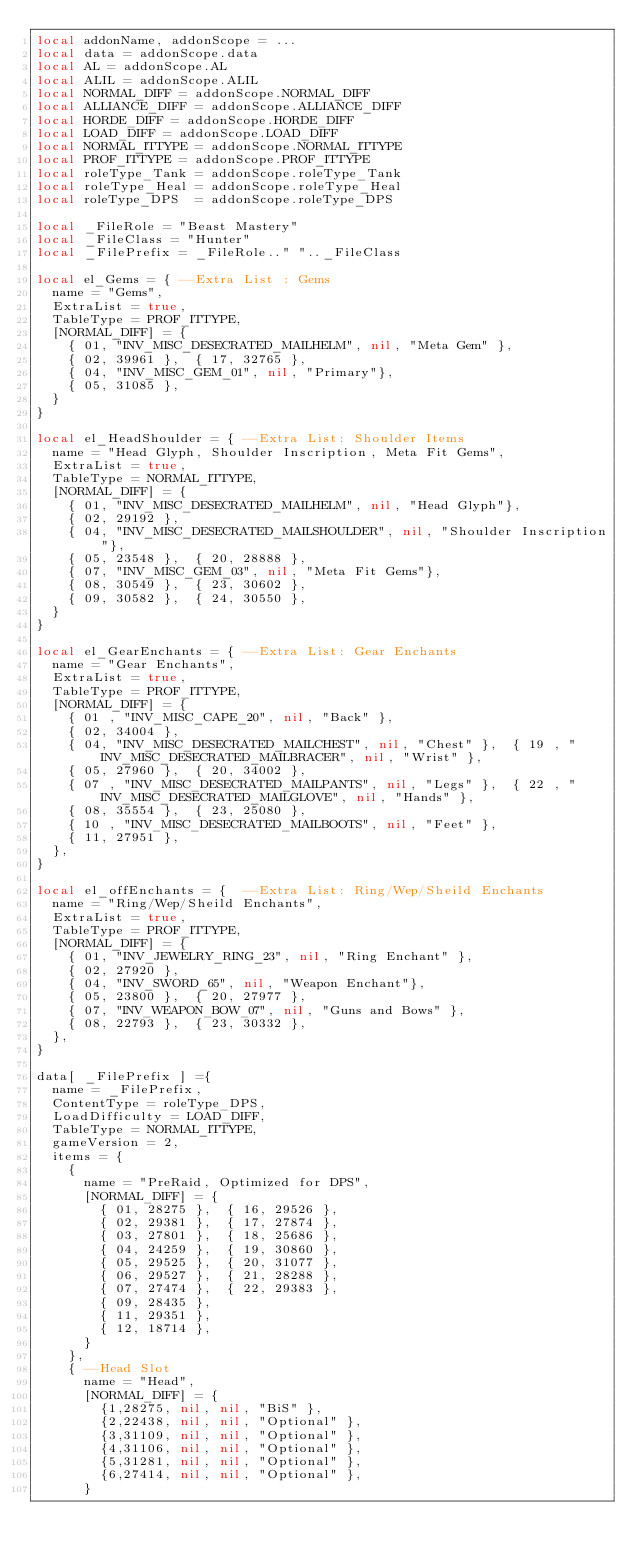Convert code to text. <code><loc_0><loc_0><loc_500><loc_500><_Lua_>local addonName, addonScope = ...
local data = addonScope.data
local AL = addonScope.AL
local ALIL = addonScope.ALIL
local NORMAL_DIFF = addonScope.NORMAL_DIFF
local ALLIANCE_DIFF = addonScope.ALLIANCE_DIFF
local HORDE_DIFF = addonScope.HORDE_DIFF
local LOAD_DIFF = addonScope.LOAD_DIFF
local NORMAL_ITTYPE = addonScope.NORMAL_ITTYPE
local PROF_ITTYPE = addonScope.PROF_ITTYPE
local roleType_Tank = addonScope.roleType_Tank
local roleType_Heal = addonScope.roleType_Heal
local roleType_DPS  = addonScope.roleType_DPS 

local _FileRole = "Beast Mastery"
local _FileClass = "Hunter"
local _FilePrefix = _FileRole.." ".._FileClass

local el_Gems = {	--Extra List : Gems
	name = "Gems",
	ExtraList = true,
	TableType = PROF_ITTYPE,
	[NORMAL_DIFF] = {
		{ 01, "INV_MISC_DESECRATED_MAILHELM", nil, "Meta Gem" },
		{ 02, 39961 },	{ 17, 32765 },
		{ 04, "INV_MISC_GEM_01", nil, "Primary"},
		{ 05, 31085 },
	}
}

local el_HeadShoulder = {	--Extra List: Shoulder Items
	name = "Head Glyph, Shoulder Inscription, Meta Fit Gems",
	ExtraList = true,
	TableType = NORMAL_ITTYPE,
	[NORMAL_DIFF] = {
		{ 01, "INV_MISC_DESECRATED_MAILHELM", nil, "Head Glyph"},
		{ 02, 29192 },
		{ 04, "INV_MISC_DESECRATED_MAILSHOULDER", nil, "Shoulder Inscription"},
		{ 05, 23548 },	{ 20, 28888 },
		{ 07, "INV_MISC_GEM_03", nil, "Meta Fit Gems"},
		{ 08, 30549 },	{ 23, 30602 },
		{ 09, 30582 },	{ 24, 30550 },
	}
}

local el_GearEnchants = {	--Extra List: Gear Enchants
	name = "Gear Enchants",
	ExtraList = true,
	TableType = PROF_ITTYPE,
	[NORMAL_DIFF] = {
		{ 01 , "INV_MISC_CAPE_20", nil, "Back" },	
		{ 02, 34004 },	
		{ 04, "INV_MISC_DESECRATED_MAILCHEST", nil, "Chest" },	{ 19 , "INV_MISC_DESECRATED_MAILBRACER", nil, "Wrist" },
		{ 05, 27960 },	{ 20, 34002 },
		{ 07 , "INV_MISC_DESECRATED_MAILPANTS", nil, "Legs" },	{ 22 , "INV_MISC_DESECRATED_MAILGLOVE", nil, "Hands" },
		{ 08, 35554 },	{ 23, 25080 },
		{ 10 , "INV_MISC_DESECRATED_MAILBOOTS", nil, "Feet" },	
		{ 11, 27951 },	
	},
}

local el_offEnchants = {	--Extra List: Ring/Wep/Sheild Enchants
	name = "Ring/Wep/Sheild Enchants",
	ExtraList = true,
	TableType = PROF_ITTYPE,
	[NORMAL_DIFF] = {
		{ 01, "INV_JEWELRY_RING_23", nil, "Ring Enchant" },
		{ 02, 27920 },
		{ 04, "INV_SWORD_65", nil, "Weapon Enchant"},
		{ 05, 23800 },	{ 20, 27977 },
		{ 07, "INV_WEAPON_BOW_07", nil, "Guns and Bows" },
		{ 08, 22793 },	{ 23, 30332 },
	},
}

data[ _FilePrefix ] ={
	name = _FilePrefix,
	ContentType = roleType_DPS,
	LoadDifficulty = LOAD_DIFF,
	TableType = NORMAL_ITTYPE,
	gameVersion = 2,
	items = {
		{
			name = "PreRaid, Optimized for DPS",
			[NORMAL_DIFF] = {
				{ 01, 28275 },	{ 16, 29526 },
				{ 02, 29381 },	{ 17, 27874 },
				{ 03, 27801 },	{ 18, 25686 },
				{ 04, 24259 },	{ 19, 30860 },
				{ 05, 29525 },	{ 20, 31077 },
				{ 06, 29527 },	{ 21, 28288 },
				{ 07, 27474 },	{ 22, 29383 },
				{ 09, 28435 },
				{ 11, 29351 },
				{ 12, 18714 },
			}
		},
		{	--Head Slot
			name = "Head",
			[NORMAL_DIFF] = {
				{1,28275, nil, nil, "BiS" },
				{2,22438, nil, nil, "Optional" },
				{3,31109, nil, nil, "Optional" },
				{4,31106, nil, nil, "Optional" },
				{5,31281, nil, nil, "Optional" },
				{6,27414, nil, nil, "Optional" },
			}</code> 